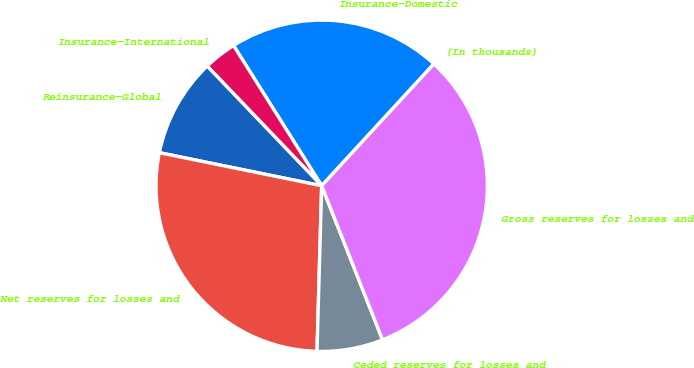Convert chart to OTSL. <chart><loc_0><loc_0><loc_500><loc_500><pie_chart><fcel>(In thousands)<fcel>Insurance-Domestic<fcel>Insurance-International<fcel>Reinsurance-Global<fcel>Net reserves for losses and<fcel>Ceded reserves for losses and<fcel>Gross reserves for losses and<nl><fcel>0.01%<fcel>20.77%<fcel>3.22%<fcel>9.65%<fcel>27.75%<fcel>6.44%<fcel>32.16%<nl></chart> 